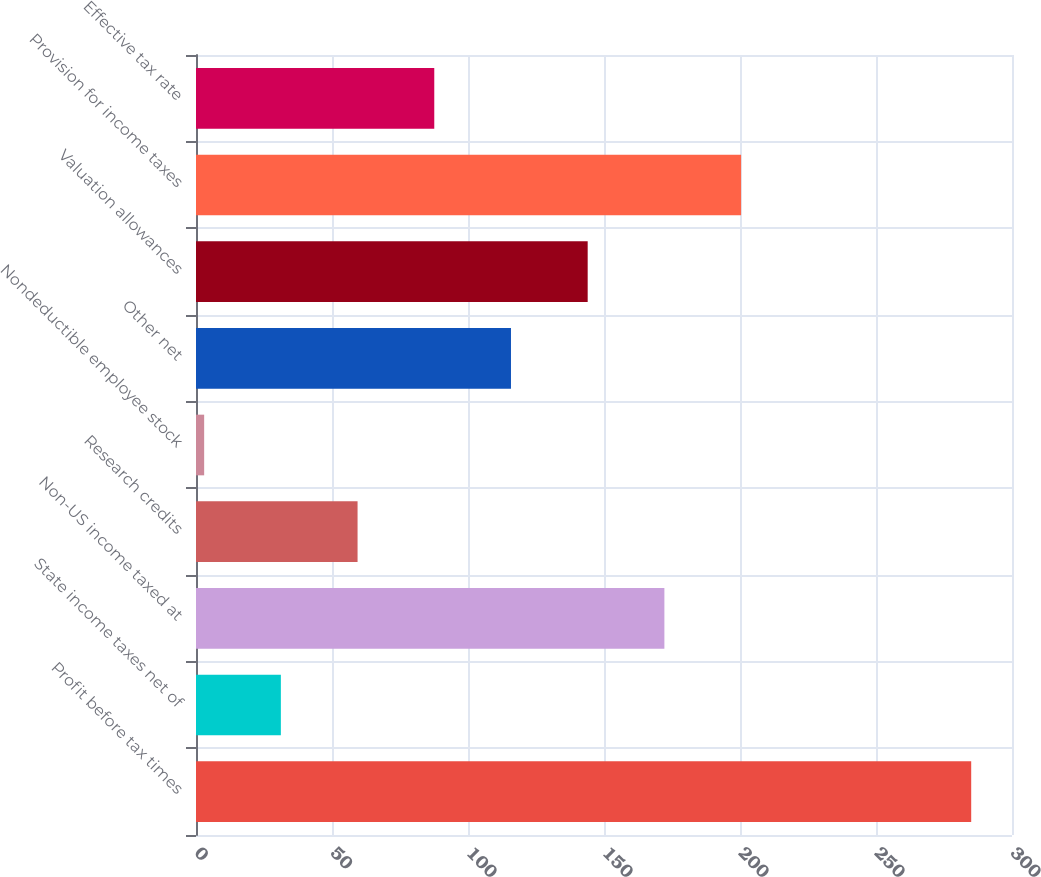<chart> <loc_0><loc_0><loc_500><loc_500><bar_chart><fcel>Profit before tax times<fcel>State income taxes net of<fcel>Non-US income taxed at<fcel>Research credits<fcel>Nondeductible employee stock<fcel>Other net<fcel>Valuation allowances<fcel>Provision for income taxes<fcel>Effective tax rate<nl><fcel>285<fcel>31.2<fcel>172.2<fcel>59.4<fcel>3<fcel>115.8<fcel>144<fcel>200.4<fcel>87.6<nl></chart> 